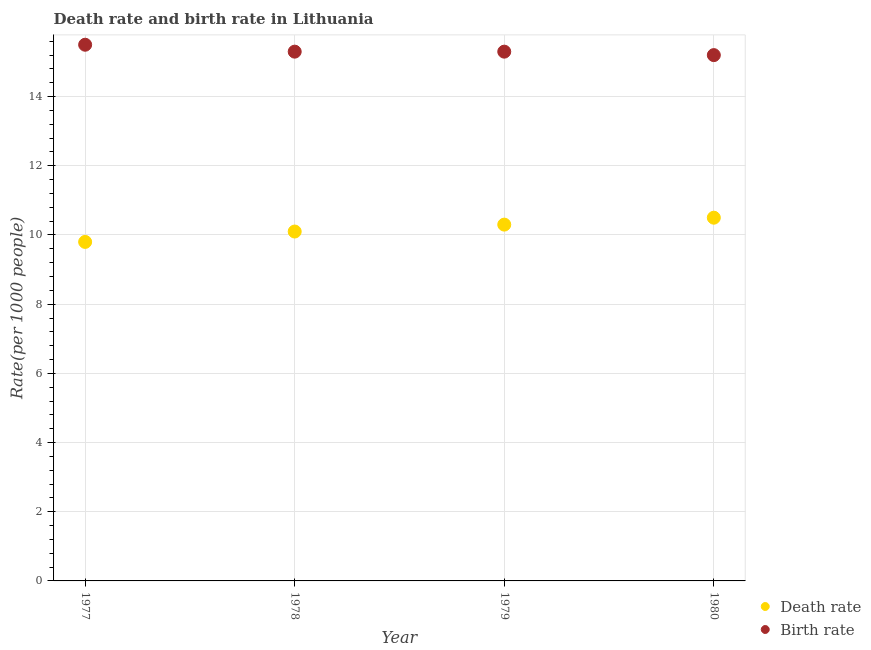What is the death rate in 1980?
Provide a short and direct response. 10.5. In which year was the death rate maximum?
Provide a short and direct response. 1980. What is the total birth rate in the graph?
Your answer should be compact. 61.3. What is the difference between the death rate in 1978 and that in 1980?
Your response must be concise. -0.4. What is the difference between the death rate in 1979 and the birth rate in 1980?
Your answer should be compact. -4.9. What is the average birth rate per year?
Make the answer very short. 15.32. In the year 1980, what is the difference between the death rate and birth rate?
Offer a terse response. -4.7. In how many years, is the death rate greater than 7.2?
Your answer should be compact. 4. What is the ratio of the death rate in 1977 to that in 1980?
Provide a succinct answer. 0.93. Is the birth rate in 1979 less than that in 1980?
Give a very brief answer. No. What is the difference between the highest and the second highest death rate?
Keep it short and to the point. 0.2. What is the difference between the highest and the lowest birth rate?
Offer a very short reply. 0.3. In how many years, is the birth rate greater than the average birth rate taken over all years?
Ensure brevity in your answer.  1. Does the death rate monotonically increase over the years?
Your answer should be compact. Yes. Is the birth rate strictly greater than the death rate over the years?
Offer a terse response. Yes. Is the birth rate strictly less than the death rate over the years?
Your response must be concise. No. What is the difference between two consecutive major ticks on the Y-axis?
Your answer should be compact. 2. Are the values on the major ticks of Y-axis written in scientific E-notation?
Ensure brevity in your answer.  No. Does the graph contain grids?
Ensure brevity in your answer.  Yes. How many legend labels are there?
Give a very brief answer. 2. How are the legend labels stacked?
Keep it short and to the point. Vertical. What is the title of the graph?
Your answer should be compact. Death rate and birth rate in Lithuania. Does "Secondary Education" appear as one of the legend labels in the graph?
Provide a succinct answer. No. What is the label or title of the Y-axis?
Offer a terse response. Rate(per 1000 people). What is the Rate(per 1000 people) in Birth rate in 1977?
Offer a terse response. 15.5. What is the Rate(per 1000 people) of Death rate in 1978?
Make the answer very short. 10.1. What is the Rate(per 1000 people) in Death rate in 1980?
Make the answer very short. 10.5. Across all years, what is the maximum Rate(per 1000 people) of Death rate?
Offer a very short reply. 10.5. Across all years, what is the maximum Rate(per 1000 people) of Birth rate?
Provide a succinct answer. 15.5. Across all years, what is the minimum Rate(per 1000 people) in Death rate?
Keep it short and to the point. 9.8. Across all years, what is the minimum Rate(per 1000 people) in Birth rate?
Keep it short and to the point. 15.2. What is the total Rate(per 1000 people) of Death rate in the graph?
Your response must be concise. 40.7. What is the total Rate(per 1000 people) in Birth rate in the graph?
Your answer should be compact. 61.3. What is the difference between the Rate(per 1000 people) in Death rate in 1977 and that in 1978?
Offer a terse response. -0.3. What is the difference between the Rate(per 1000 people) in Birth rate in 1977 and that in 1978?
Keep it short and to the point. 0.2. What is the difference between the Rate(per 1000 people) in Death rate in 1977 and that in 1979?
Ensure brevity in your answer.  -0.5. What is the difference between the Rate(per 1000 people) of Birth rate in 1977 and that in 1979?
Your response must be concise. 0.2. What is the difference between the Rate(per 1000 people) in Birth rate in 1977 and that in 1980?
Your answer should be very brief. 0.3. What is the difference between the Rate(per 1000 people) of Death rate in 1978 and that in 1979?
Your answer should be compact. -0.2. What is the difference between the Rate(per 1000 people) in Birth rate in 1978 and that in 1980?
Give a very brief answer. 0.1. What is the difference between the Rate(per 1000 people) in Death rate in 1979 and that in 1980?
Provide a short and direct response. -0.2. What is the difference between the Rate(per 1000 people) of Birth rate in 1979 and that in 1980?
Provide a succinct answer. 0.1. What is the difference between the Rate(per 1000 people) of Death rate in 1978 and the Rate(per 1000 people) of Birth rate in 1980?
Ensure brevity in your answer.  -5.1. What is the difference between the Rate(per 1000 people) of Death rate in 1979 and the Rate(per 1000 people) of Birth rate in 1980?
Your response must be concise. -4.9. What is the average Rate(per 1000 people) of Death rate per year?
Provide a succinct answer. 10.18. What is the average Rate(per 1000 people) of Birth rate per year?
Make the answer very short. 15.32. In the year 1979, what is the difference between the Rate(per 1000 people) in Death rate and Rate(per 1000 people) in Birth rate?
Offer a very short reply. -5. In the year 1980, what is the difference between the Rate(per 1000 people) of Death rate and Rate(per 1000 people) of Birth rate?
Keep it short and to the point. -4.7. What is the ratio of the Rate(per 1000 people) in Death rate in 1977 to that in 1978?
Offer a terse response. 0.97. What is the ratio of the Rate(per 1000 people) of Birth rate in 1977 to that in 1978?
Offer a terse response. 1.01. What is the ratio of the Rate(per 1000 people) in Death rate in 1977 to that in 1979?
Your answer should be very brief. 0.95. What is the ratio of the Rate(per 1000 people) in Birth rate in 1977 to that in 1979?
Ensure brevity in your answer.  1.01. What is the ratio of the Rate(per 1000 people) in Death rate in 1977 to that in 1980?
Offer a terse response. 0.93. What is the ratio of the Rate(per 1000 people) of Birth rate in 1977 to that in 1980?
Give a very brief answer. 1.02. What is the ratio of the Rate(per 1000 people) of Death rate in 1978 to that in 1979?
Provide a succinct answer. 0.98. What is the ratio of the Rate(per 1000 people) of Birth rate in 1978 to that in 1979?
Your response must be concise. 1. What is the ratio of the Rate(per 1000 people) in Death rate in 1978 to that in 1980?
Offer a terse response. 0.96. What is the ratio of the Rate(per 1000 people) of Birth rate in 1978 to that in 1980?
Your response must be concise. 1.01. What is the ratio of the Rate(per 1000 people) of Death rate in 1979 to that in 1980?
Offer a very short reply. 0.98. What is the ratio of the Rate(per 1000 people) of Birth rate in 1979 to that in 1980?
Give a very brief answer. 1.01. What is the difference between the highest and the second highest Rate(per 1000 people) in Death rate?
Make the answer very short. 0.2. What is the difference between the highest and the second highest Rate(per 1000 people) in Birth rate?
Your answer should be compact. 0.2. What is the difference between the highest and the lowest Rate(per 1000 people) in Death rate?
Provide a succinct answer. 0.7. 